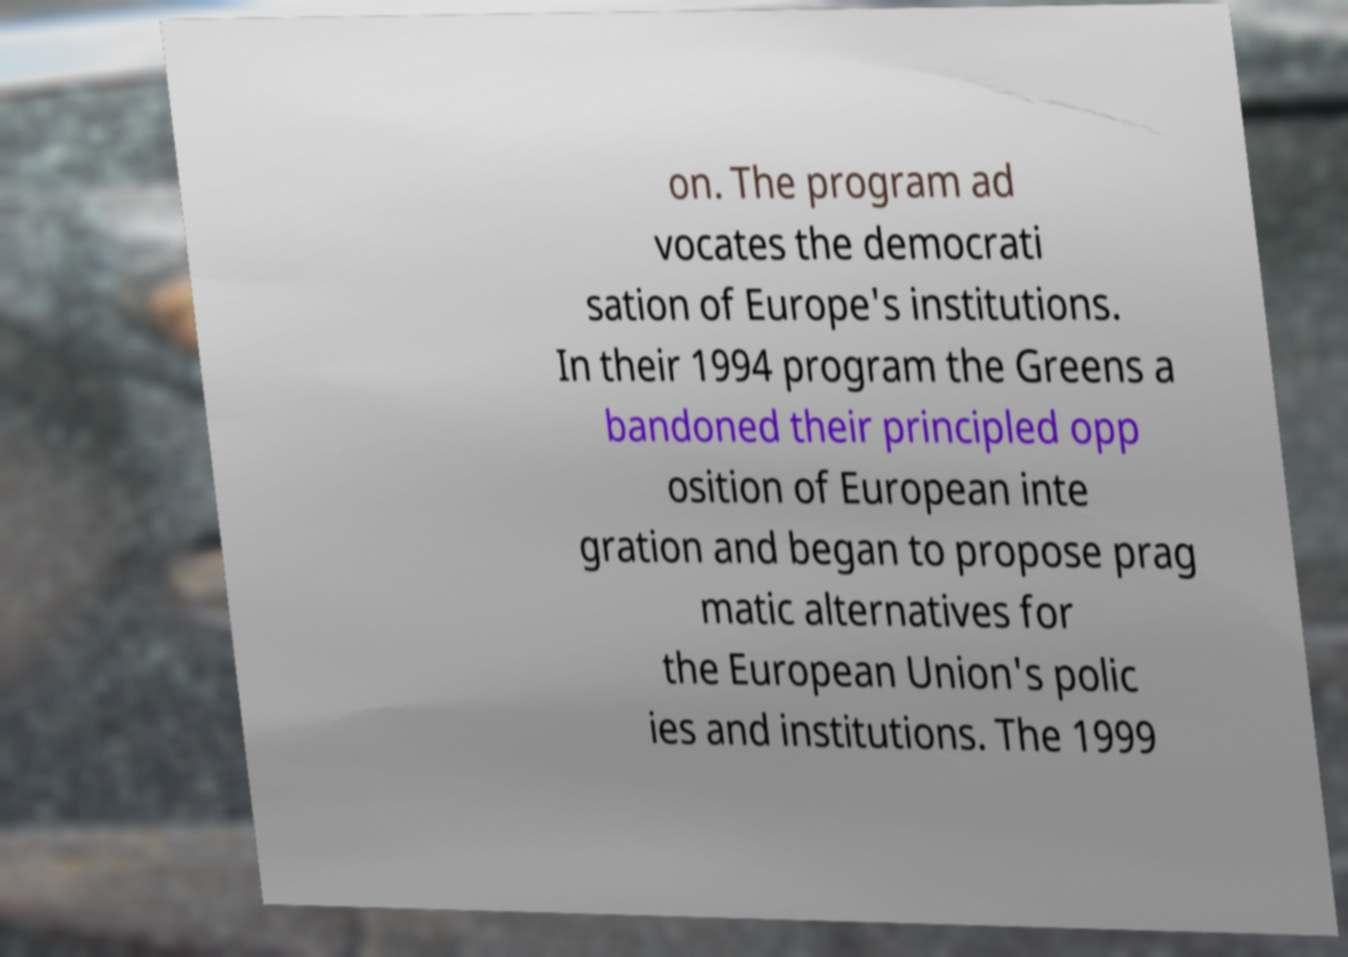Please identify and transcribe the text found in this image. on. The program ad vocates the democrati sation of Europe's institutions. In their 1994 program the Greens a bandoned their principled opp osition of European inte gration and began to propose prag matic alternatives for the European Union's polic ies and institutions. The 1999 